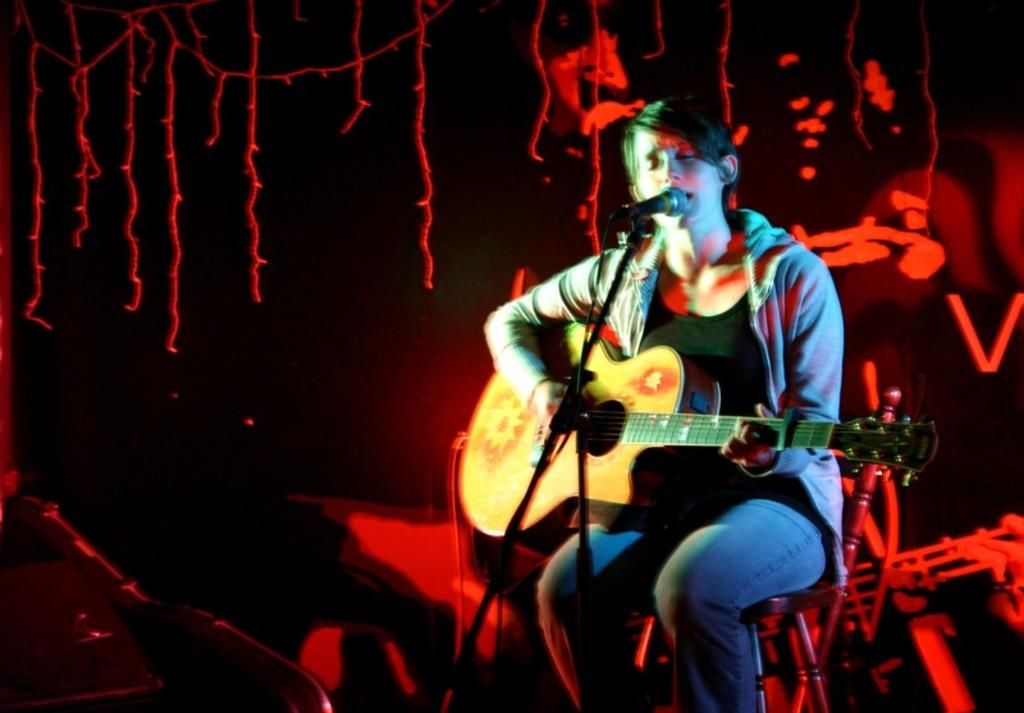What is the person in the image doing? The person in the image is playing a guitar. What object is present in the image that is commonly used for amplifying sound? There is a microphone in the image. How many kittens are playing with the guitar strings in the image? There are no kittens present in the image. What is the plot of the story being told through the image? The image does not depict a story or plot; it simply shows a person playing a guitar and a microphone. 